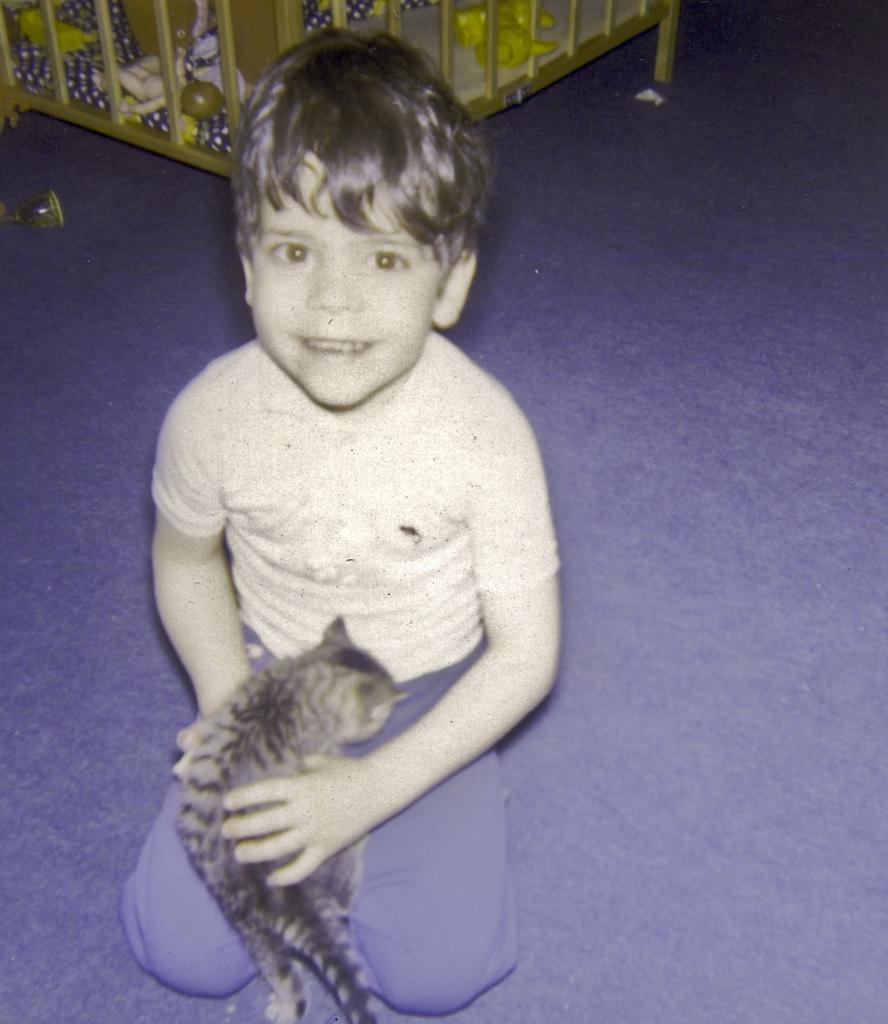In one or two sentences, can you explain what this image depicts? there is a boy sitting on the floor and holding a toy. Behind him there is a box with toys in it. 